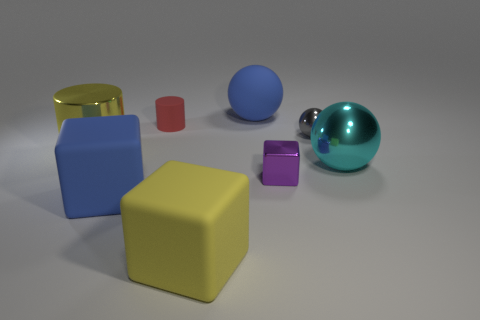There is a thing that is the same color as the metallic cylinder; what is its size?
Offer a terse response. Large. There is a big thing that is the same color as the big matte sphere; what is its material?
Give a very brief answer. Rubber. The blue thing that is the same shape as the large cyan thing is what size?
Provide a succinct answer. Large. Are there any other things that are the same size as the red matte cylinder?
Offer a terse response. Yes. Does the large blue object in front of the cyan thing have the same material as the big yellow cylinder?
Give a very brief answer. No. There is another shiny thing that is the same shape as the small gray thing; what is its color?
Ensure brevity in your answer.  Cyan. What number of other objects are the same color as the big rubber ball?
Your answer should be compact. 1. Is the shape of the large blue matte object in front of the red matte cylinder the same as the big blue thing to the right of the yellow block?
Your response must be concise. No. How many spheres are cyan things or metallic objects?
Provide a short and direct response. 2. Are there fewer cylinders behind the matte cylinder than large yellow rubber objects?
Make the answer very short. Yes. 